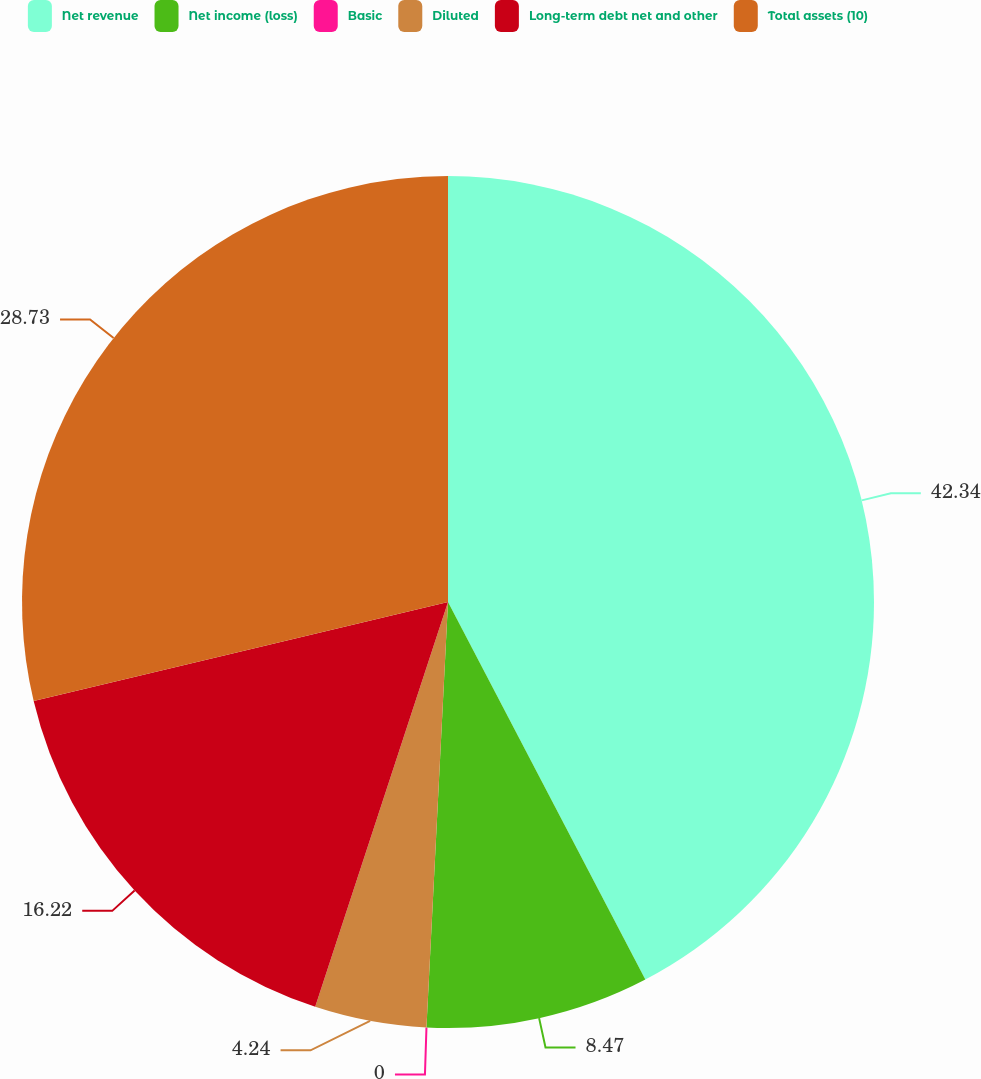Convert chart. <chart><loc_0><loc_0><loc_500><loc_500><pie_chart><fcel>Net revenue<fcel>Net income (loss)<fcel>Basic<fcel>Diluted<fcel>Long-term debt net and other<fcel>Total assets (10)<nl><fcel>42.33%<fcel>8.47%<fcel>0.0%<fcel>4.24%<fcel>16.22%<fcel>28.73%<nl></chart> 